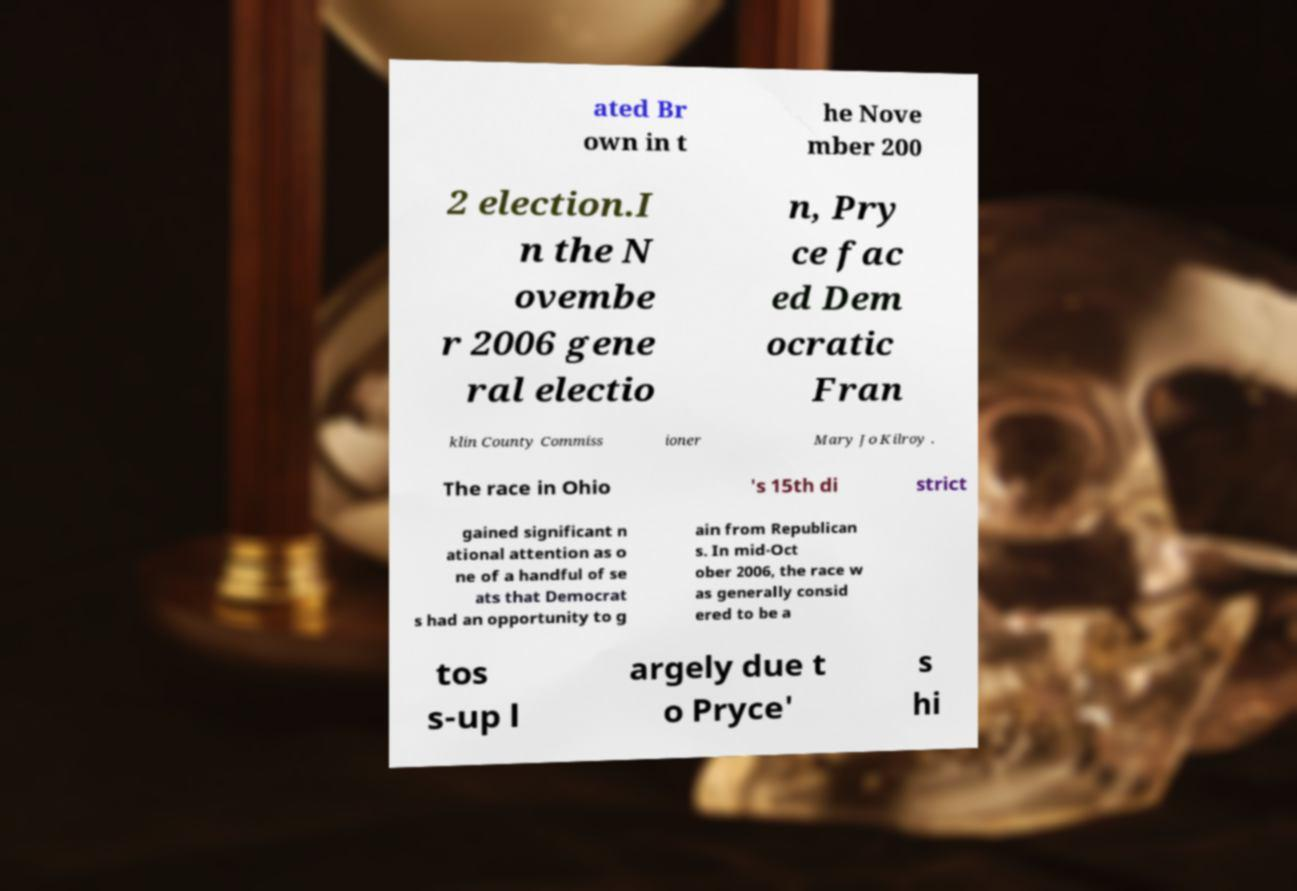Could you assist in decoding the text presented in this image and type it out clearly? ated Br own in t he Nove mber 200 2 election.I n the N ovembe r 2006 gene ral electio n, Pry ce fac ed Dem ocratic Fran klin County Commiss ioner Mary Jo Kilroy . The race in Ohio 's 15th di strict gained significant n ational attention as o ne of a handful of se ats that Democrat s had an opportunity to g ain from Republican s. In mid-Oct ober 2006, the race w as generally consid ered to be a tos s-up l argely due t o Pryce' s hi 